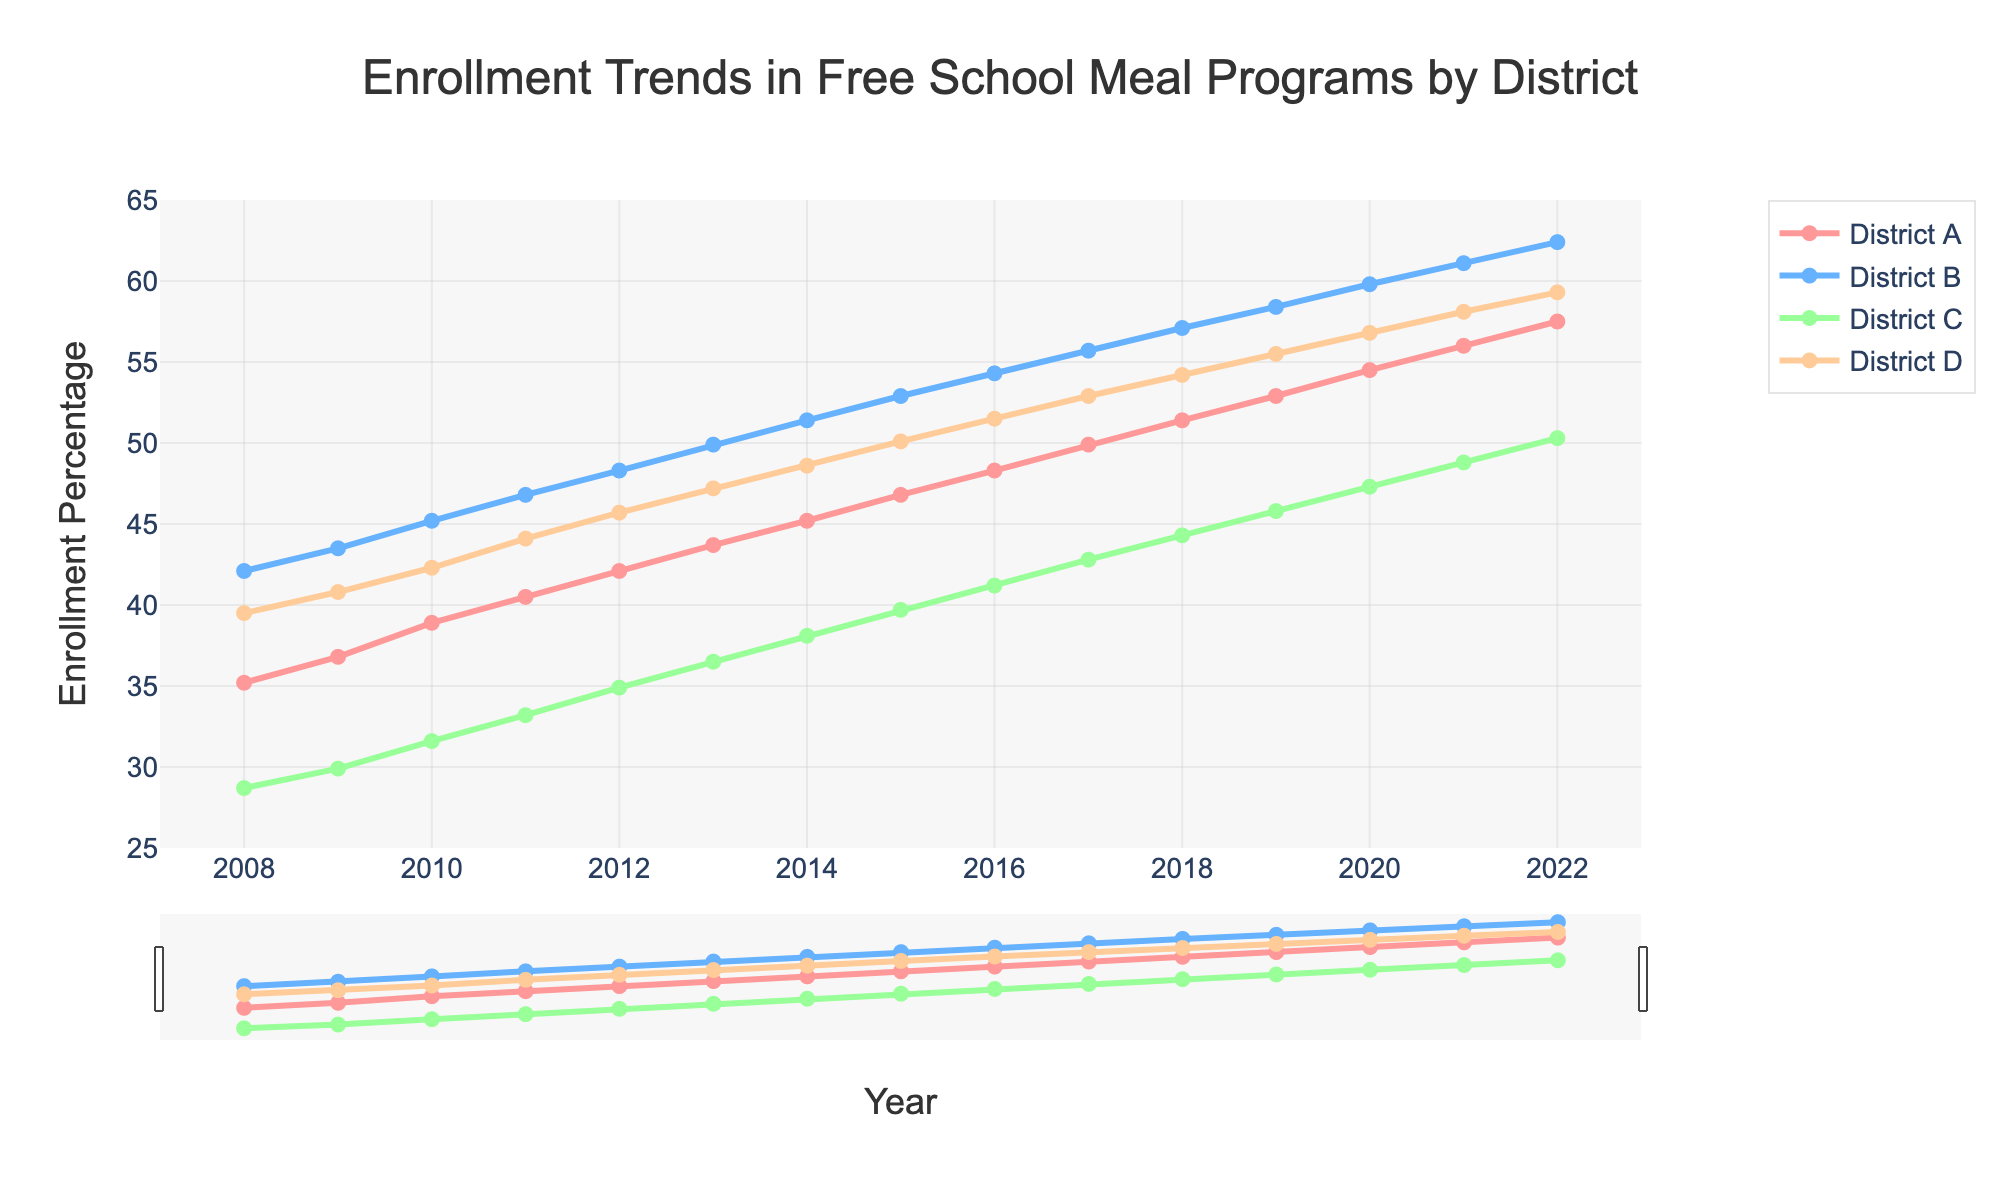What is the overall trend in enrollment in free school meal programs in District A from 2008 to 2022? The plot shows a steady increase in enrollment percentage over time in District A, starting from around 35.2% in 2008 and rising to about 57.5% in 2022. This indicates a positive trend.
Answer: Increasing Which district had the highest enrollment percentage in 2022? The plot indicates that District B had the highest enrollment percentage in 2022, approximately 62.4%.
Answer: District B Between which years did District C see the largest increase in enrollment percentage? By examining the slopes of the line segments for District C in the plot, the steepest increase appears to be between 2021 and 2022. Enrollment grew from about 48.8% in 2021 to 50.3% in 2022, showing the largest jump.
Answer: 2021 to 2022 Compare the enrollment percentages of District D and District A in 2010. Which one is higher, and by how much? In 2010, the enrollment percentage for District A is around 38.9%, and for District D, it is about 42.3%. By comparing the two, District D is higher by 42.3% - 38.9% = 3.4%.
Answer: District D by 3.4% What is the average enrollment percentage for District B over the 15 years shown? The enrollment percentages for District B over 15 years are summed up (42.1 + 43.5 + 45.2 + 46.8 + 48.3 + 49.9 + 51.4 + 52.9 + 54.3 + 55.7 + 57.1 + 58.4 + 59.8 + 61.1 + 62.4) = 789.9. To find the average, divide by 15: 789.9 / 15 = 52.66.
Answer: 52.66 How does the enrollment in District C in 2020 compare to the enrollment in District D in 2020? The plot indicates that in 2020, District C had an enrollment percentage of 47.3%, whereas District D had 56.8%. Thus, District D had a higher enrollment by 56.8% - 47.3% = 9.5%.
Answer: District D by 9.5% What color represents District A in the plot? The plot uses a specific color scheme, where District A is represented by a line and markers colored in red.
Answer: Red Which district shows the slowest growth in enrollment percentages from 2008 to 2022, and how can you tell? By comparing the slopes of the lines for each district, District C shows the slowest growth. It starts at 28.7% in 2008 and only reaches about 50.3% in 2022, indicating a slower growth rate compared to the other districts.
Answer: District C By what percentage did the enrollment in District B increase from 2018 to 2022? In 2018, District B's enrollment was 57.1%, and in 2022, it was 62.4%. The percentage increase is calculated as ((62.4 - 57.1) / 57.1) * 100 = 9.28%.
Answer: 9.28% 